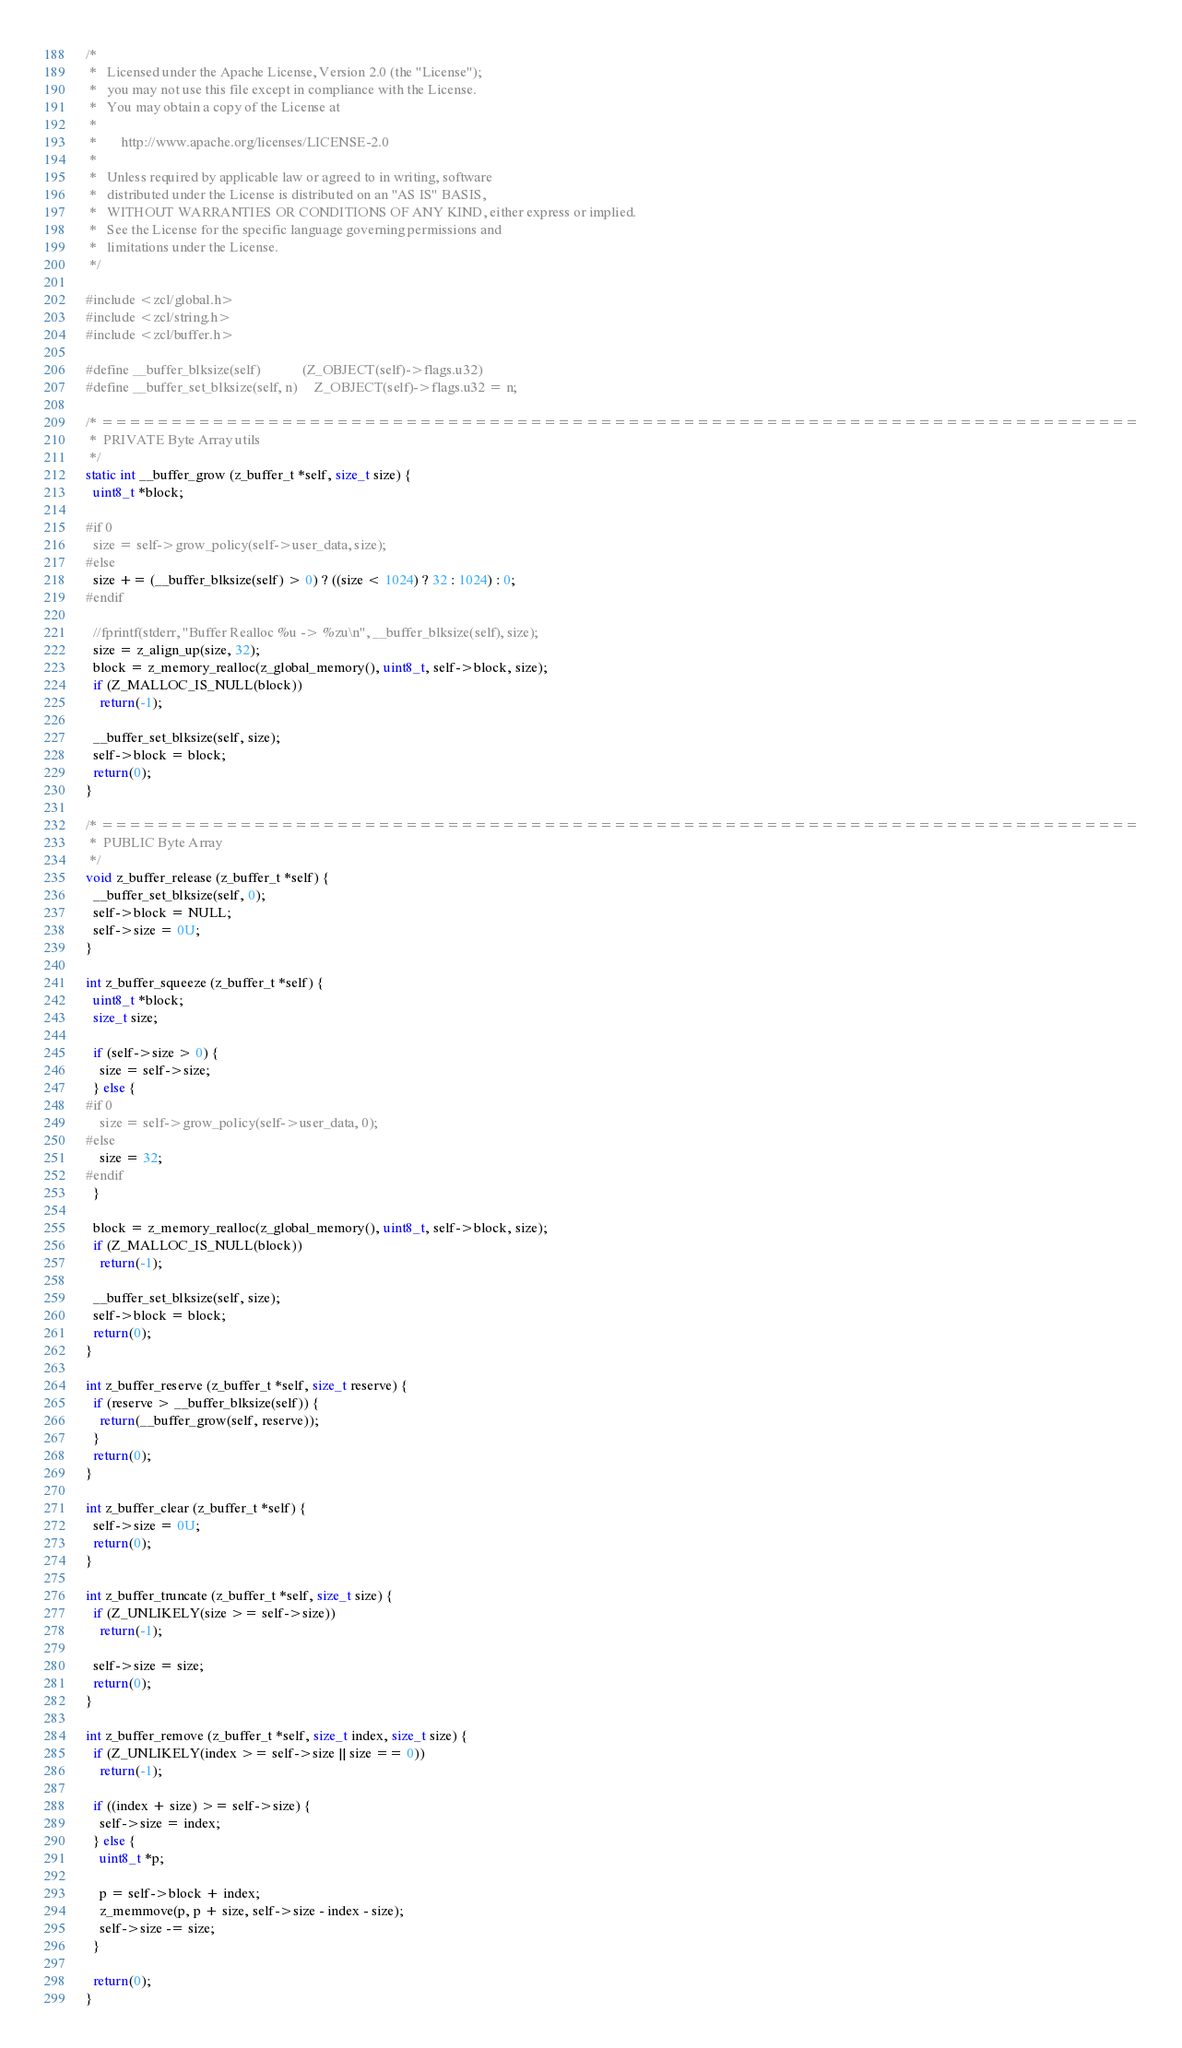<code> <loc_0><loc_0><loc_500><loc_500><_C_>/*
 *   Licensed under the Apache License, Version 2.0 (the "License");
 *   you may not use this file except in compliance with the License.
 *   You may obtain a copy of the License at
 *
 *       http://www.apache.org/licenses/LICENSE-2.0
 *
 *   Unless required by applicable law or agreed to in writing, software
 *   distributed under the License is distributed on an "AS IS" BASIS,
 *   WITHOUT WARRANTIES OR CONDITIONS OF ANY KIND, either express or implied.
 *   See the License for the specific language governing permissions and
 *   limitations under the License.
 */

#include <zcl/global.h>
#include <zcl/string.h>
#include <zcl/buffer.h>

#define __buffer_blksize(self)            (Z_OBJECT(self)->flags.u32)
#define __buffer_set_blksize(self, n)     Z_OBJECT(self)->flags.u32 = n;

/* ===========================================================================
 *  PRIVATE Byte Array utils
 */
static int __buffer_grow (z_buffer_t *self, size_t size) {
  uint8_t *block;

#if 0
  size = self->grow_policy(self->user_data, size);
#else
  size += (__buffer_blksize(self) > 0) ? ((size < 1024) ? 32 : 1024) : 0;
#endif

  //fprintf(stderr, "Buffer Realloc %u -> %zu\n", __buffer_blksize(self), size);
  size = z_align_up(size, 32);
  block = z_memory_realloc(z_global_memory(), uint8_t, self->block, size);
  if (Z_MALLOC_IS_NULL(block))
    return(-1);

  __buffer_set_blksize(self, size);
  self->block = block;
  return(0);
}

/* ===========================================================================
 *  PUBLIC Byte Array
 */
void z_buffer_release (z_buffer_t *self) {
  __buffer_set_blksize(self, 0);
  self->block = NULL;
  self->size = 0U;
}

int z_buffer_squeeze (z_buffer_t *self) {
  uint8_t *block;
  size_t size;

  if (self->size > 0) {
    size = self->size;
  } else {
#if 0
    size = self->grow_policy(self->user_data, 0);
#else
    size = 32;
#endif
  }

  block = z_memory_realloc(z_global_memory(), uint8_t, self->block, size);
  if (Z_MALLOC_IS_NULL(block))
    return(-1);

  __buffer_set_blksize(self, size);
  self->block = block;
  return(0);
}

int z_buffer_reserve (z_buffer_t *self, size_t reserve) {
  if (reserve > __buffer_blksize(self)) {
    return(__buffer_grow(self, reserve));
  }
  return(0);
}

int z_buffer_clear (z_buffer_t *self) {
  self->size = 0U;
  return(0);
}

int z_buffer_truncate (z_buffer_t *self, size_t size) {
  if (Z_UNLIKELY(size >= self->size))
    return(-1);

  self->size = size;
  return(0);
}

int z_buffer_remove (z_buffer_t *self, size_t index, size_t size) {
  if (Z_UNLIKELY(index >= self->size || size == 0))
    return(-1);

  if ((index + size) >= self->size) {
    self->size = index;
  } else {
    uint8_t *p;

    p = self->block + index;
    z_memmove(p, p + size, self->size - index - size);
    self->size -= size;
  }

  return(0);
}
</code> 